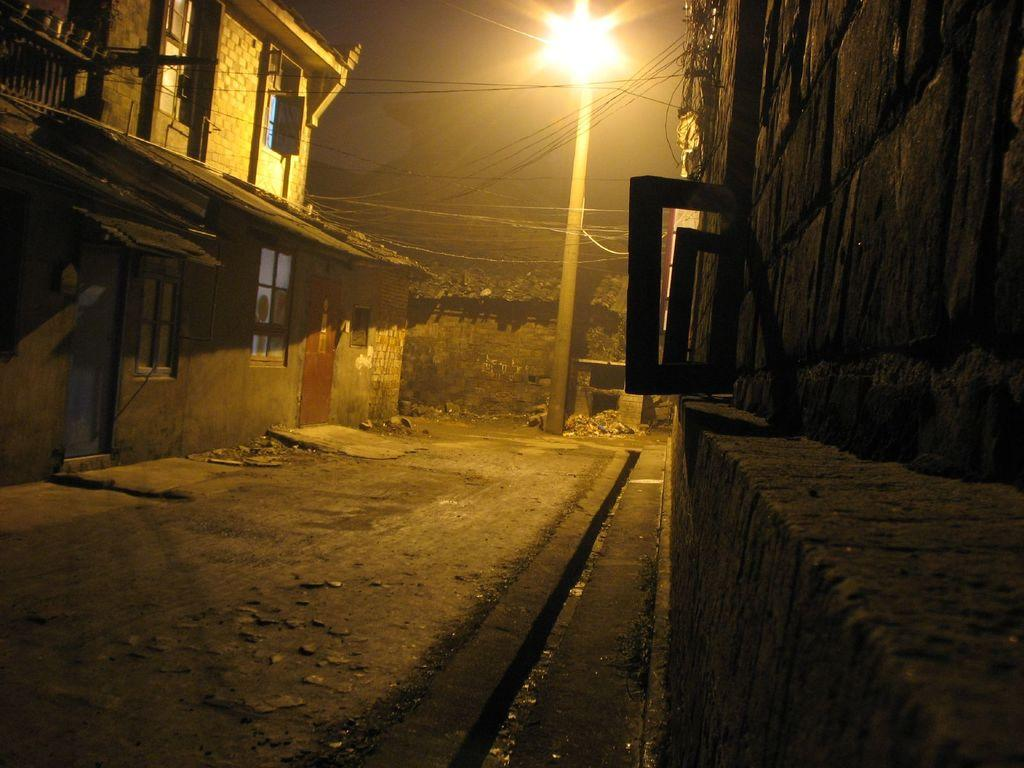What type of structures can be seen in the image? There are buildings with windows in the image. What is the ground surface like in the image? There is a pathway and stones visible in the image. What is the purpose of the street pole in the image? The street pole is likely used for supporting wires or signs. What is visible in the sky in the image? The sky is visible in the image. What type of fan can be seen in the image? There is no fan present in the image. What type of pleasure can be derived from the image? The image is not meant to provide pleasure; it is a visual representation of a scene. 